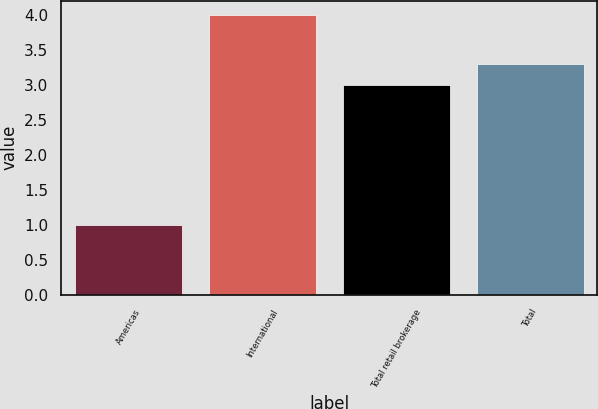<chart> <loc_0><loc_0><loc_500><loc_500><bar_chart><fcel>Americas<fcel>International<fcel>Total retail brokerage<fcel>Total<nl><fcel>1<fcel>4<fcel>3<fcel>3.3<nl></chart> 